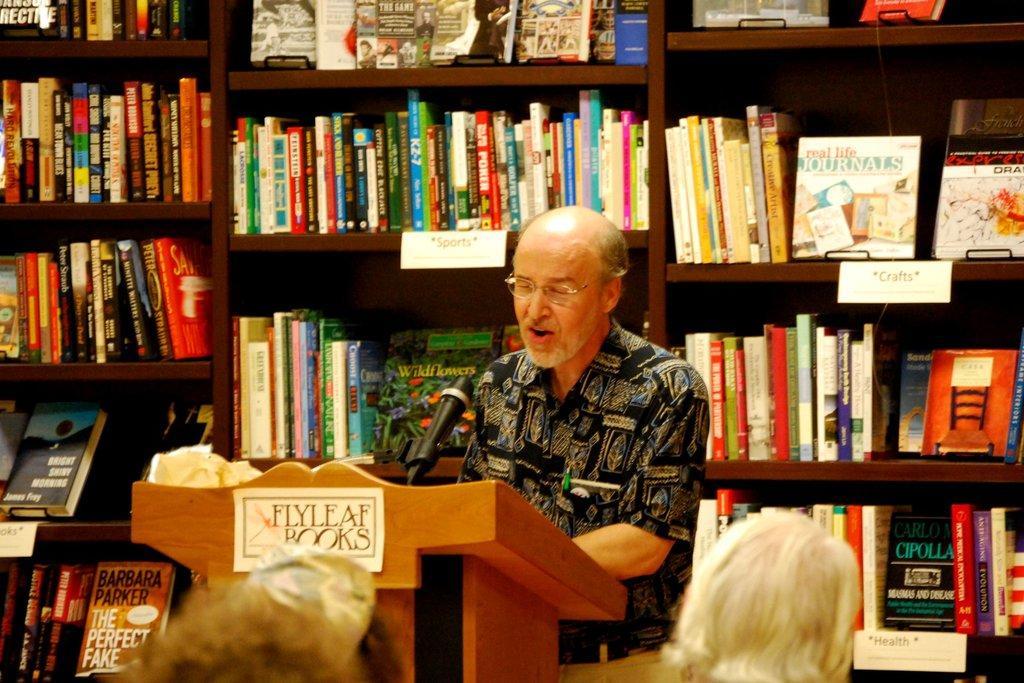How would you summarize this image in a sentence or two? In this image I can see a man is standing, I can see he is wearing black shirt, belt and specs. I can also see a podium, few boards and number of books on these shelves. I can also see something is written on these boards. 